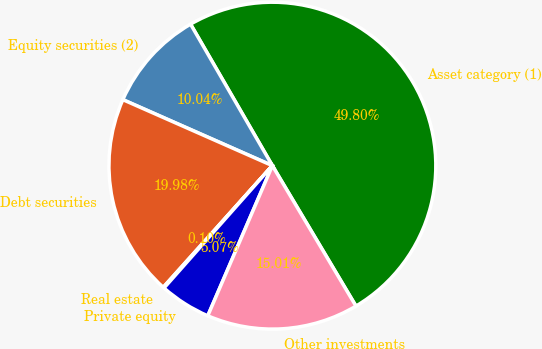Convert chart to OTSL. <chart><loc_0><loc_0><loc_500><loc_500><pie_chart><fcel>Asset category (1)<fcel>Equity securities (2)<fcel>Debt securities<fcel>Real estate<fcel>Private equity<fcel>Other investments<nl><fcel>49.8%<fcel>10.04%<fcel>19.98%<fcel>0.1%<fcel>5.07%<fcel>15.01%<nl></chart> 